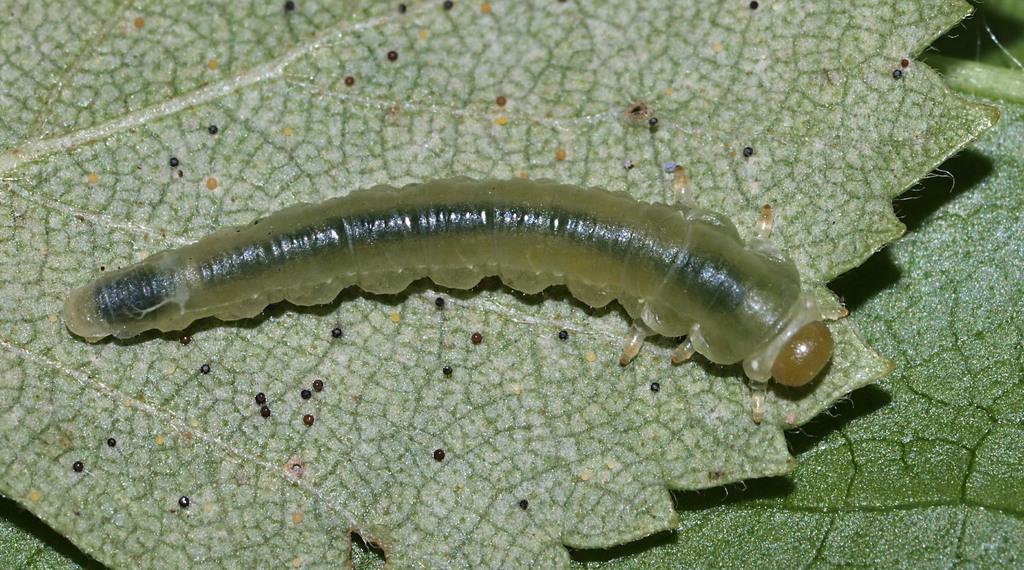What is the main subject of the image? The main subject of the image is a larva on a leaf. What can be seen on the leaf with the larva? There are black color objects on the leaf in the image. What is the price of the horse in the image? There is no horse present in the image, so it is not possible to determine the price of a horse. 